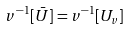<formula> <loc_0><loc_0><loc_500><loc_500>v ^ { - 1 } [ \bar { U } ] = v ^ { - 1 } [ U _ { v } ]</formula> 